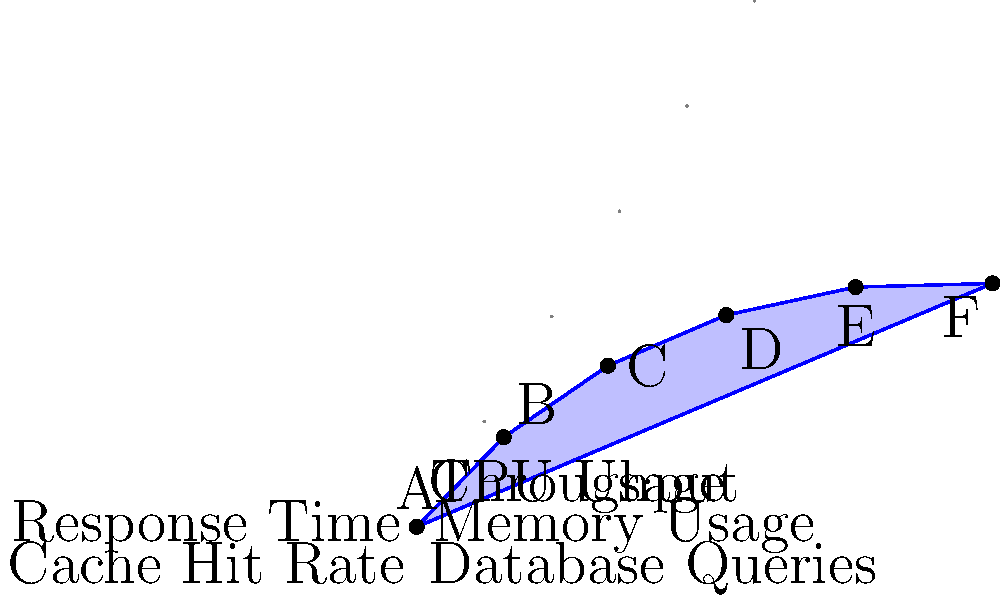In the polar plot representing Django's performance metrics, which metric shows the highest relative performance, and what could this indicate about the framework's strengths? To answer this question, we need to analyze the polar plot and interpret the data:

1. The plot shows six performance metrics for Django:
   - Response Time
   - Throughput
   - CPU Usage
   - Memory Usage
   - Database Queries
   - Cache Hit Rate

2. Each metric is represented by a radial axis, where the distance from the center indicates the relative performance (higher is better).

3. Examining the plot, we can see that:
   - Response Time (A) has the highest value at 0.9
   - Throughput (B) is second at 0.8
   - CPU Usage (C) is third at 0.7
   - Memory Usage (D) is fourth at 0.6
   - Database Queries (E) is fifth at 0.5
   - Cache Hit Rate (F) is lowest at 0.4

4. The highest relative performance is shown by Response Time (A) at 0.9.

5. This high score in Response Time could indicate that Django excels in:
   - Efficient request handling
   - Quick processing of web requests
   - Optimized middleware and view functions
   - Fast template rendering

6. The high Response Time performance suggests that Django is particularly strong in delivering quick responses to user requests, which is crucial for web applications.
Answer: Response Time; indicates Django's strength in efficient request handling and quick processing. 